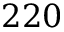Convert formula to latex. <formula><loc_0><loc_0><loc_500><loc_500>2 2 0</formula> 